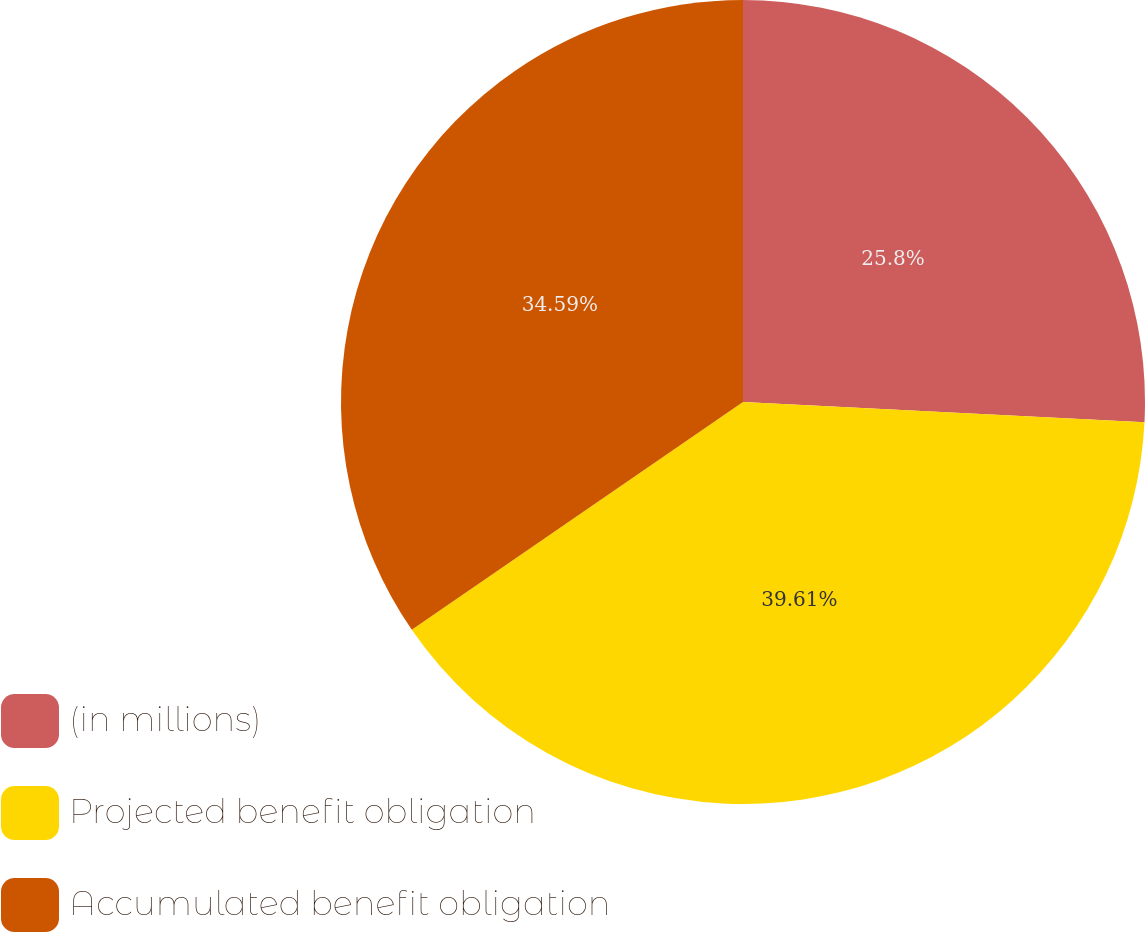Convert chart. <chart><loc_0><loc_0><loc_500><loc_500><pie_chart><fcel>(in millions)<fcel>Projected benefit obligation<fcel>Accumulated benefit obligation<nl><fcel>25.8%<fcel>39.61%<fcel>34.59%<nl></chart> 